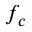Convert formula to latex. <formula><loc_0><loc_0><loc_500><loc_500>f _ { c }</formula> 